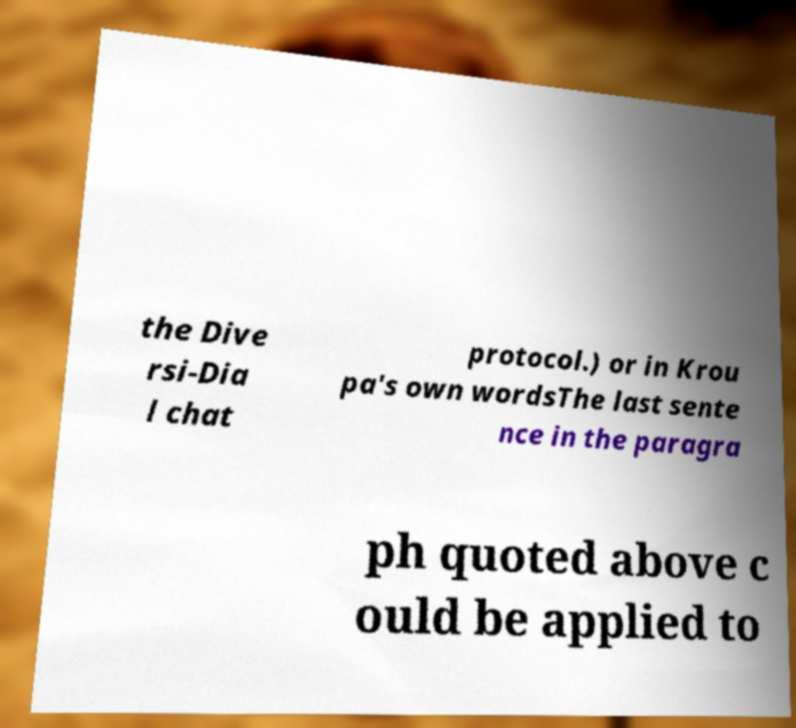For documentation purposes, I need the text within this image transcribed. Could you provide that? the Dive rsi-Dia l chat protocol.) or in Krou pa's own wordsThe last sente nce in the paragra ph quoted above c ould be applied to 